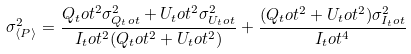<formula> <loc_0><loc_0><loc_500><loc_500>\sigma _ { \langle P \rangle } ^ { 2 } = \frac { Q _ { t } o t ^ { 2 } \sigma _ { Q _ { t } o t } ^ { 2 } + U _ { t } o t ^ { 2 } \sigma _ { U _ { t } o t } ^ { 2 } } { I _ { t } o t ^ { 2 } ( Q _ { t } o t ^ { 2 } + U _ { t } o t ^ { 2 } ) } + \frac { ( Q _ { t } o t ^ { 2 } + U _ { t } o t ^ { 2 } ) \sigma _ { I _ { t } o t } ^ { 2 } } { I _ { t } o t ^ { 4 } }</formula> 